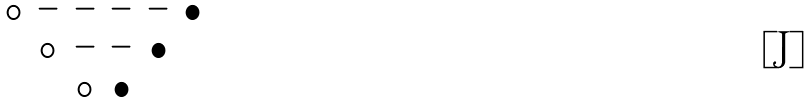<formula> <loc_0><loc_0><loc_500><loc_500>\begin{matrix} \circ & - & - & - & - & \bullet \\ & \circ & - & - & \bullet & \\ & & \circ & \bullet & & \\ \end{matrix}</formula> 